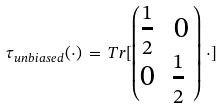Convert formula to latex. <formula><loc_0><loc_0><loc_500><loc_500>\tau _ { u n b i a s e d } ( \cdot ) \, = \, T r [ \begin{pmatrix} \frac { 1 } { 2 } & 0 \\ 0 & \frac { 1 } { 2 } \ \end{pmatrix} \, \cdot ]</formula> 